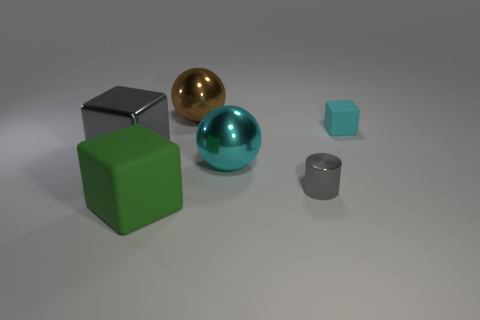Subtract all big cubes. How many cubes are left? 1 Subtract all gray cubes. How many cubes are left? 2 Subtract all balls. How many objects are left? 4 Subtract all big cyan metal objects. Subtract all small green metal cylinders. How many objects are left? 5 Add 5 large brown balls. How many large brown balls are left? 6 Add 4 cyan shiny blocks. How many cyan shiny blocks exist? 4 Add 2 tiny red cubes. How many objects exist? 8 Subtract 0 brown cubes. How many objects are left? 6 Subtract 1 balls. How many balls are left? 1 Subtract all yellow cubes. Subtract all red cylinders. How many cubes are left? 3 